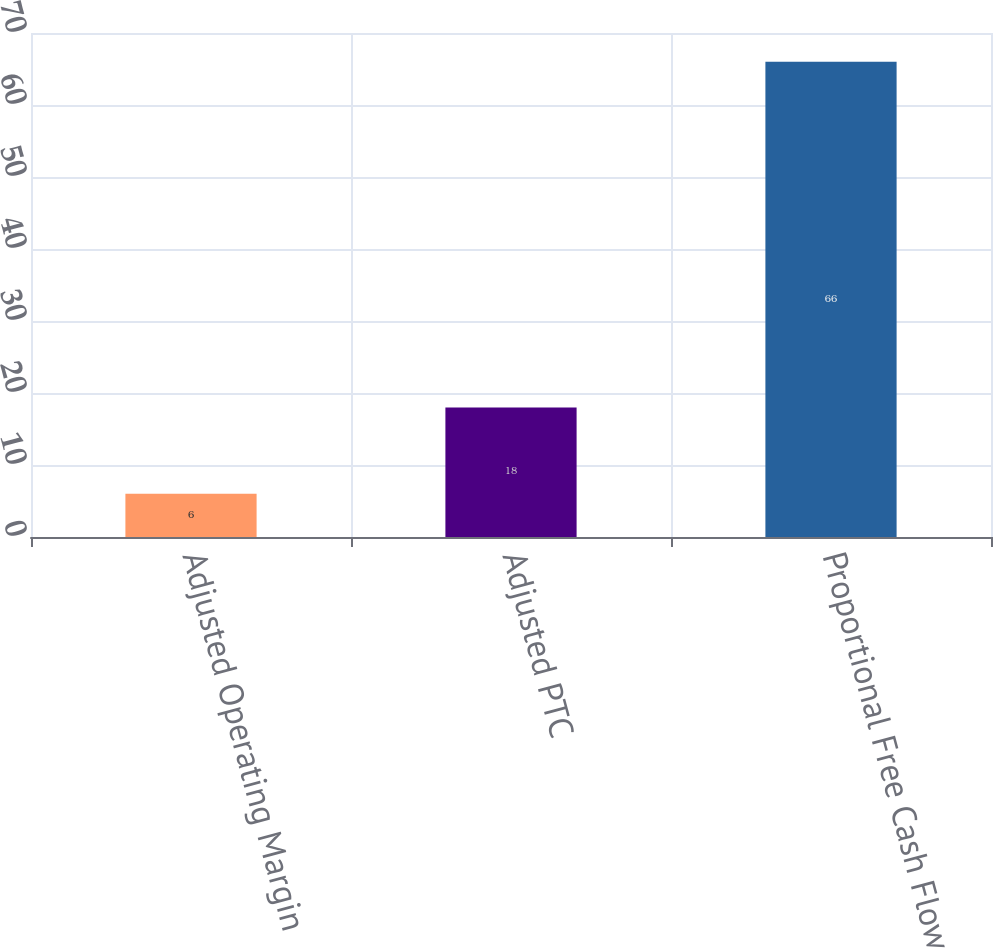Convert chart. <chart><loc_0><loc_0><loc_500><loc_500><bar_chart><fcel>Adjusted Operating Margin<fcel>Adjusted PTC<fcel>Proportional Free Cash Flow<nl><fcel>6<fcel>18<fcel>66<nl></chart> 